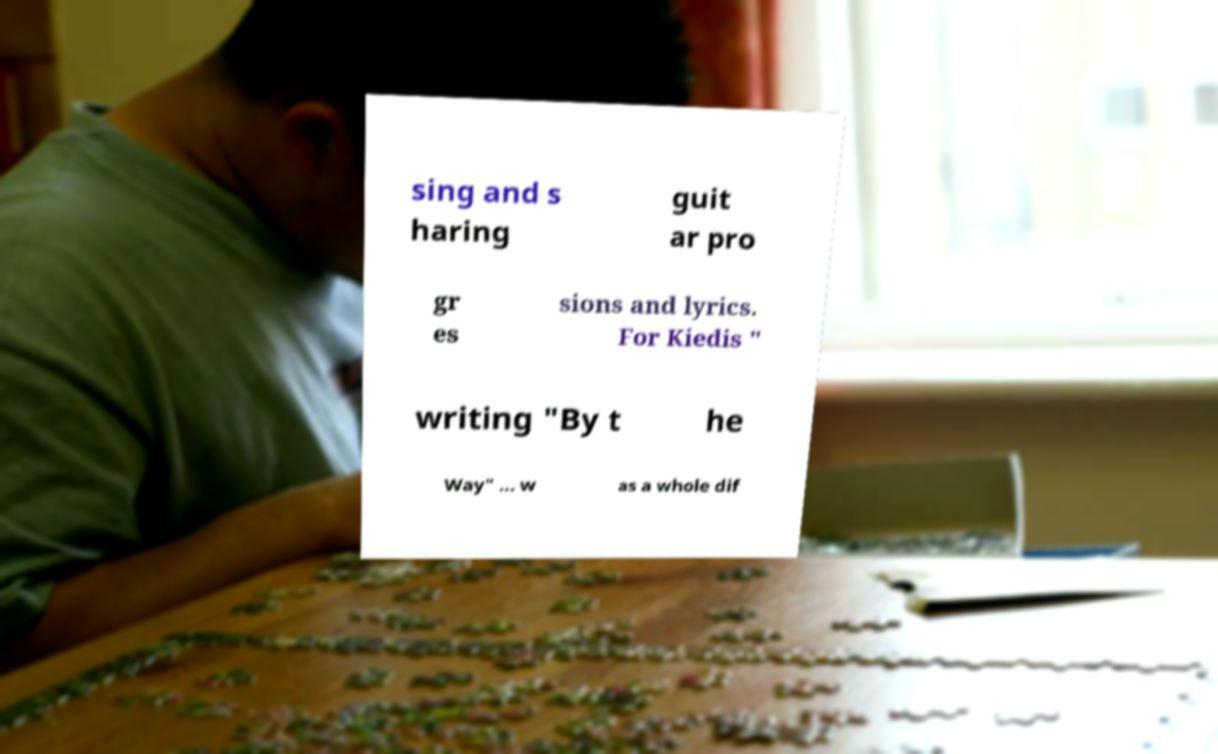Could you extract and type out the text from this image? sing and s haring guit ar pro gr es sions and lyrics. For Kiedis " writing "By t he Way" ... w as a whole dif 